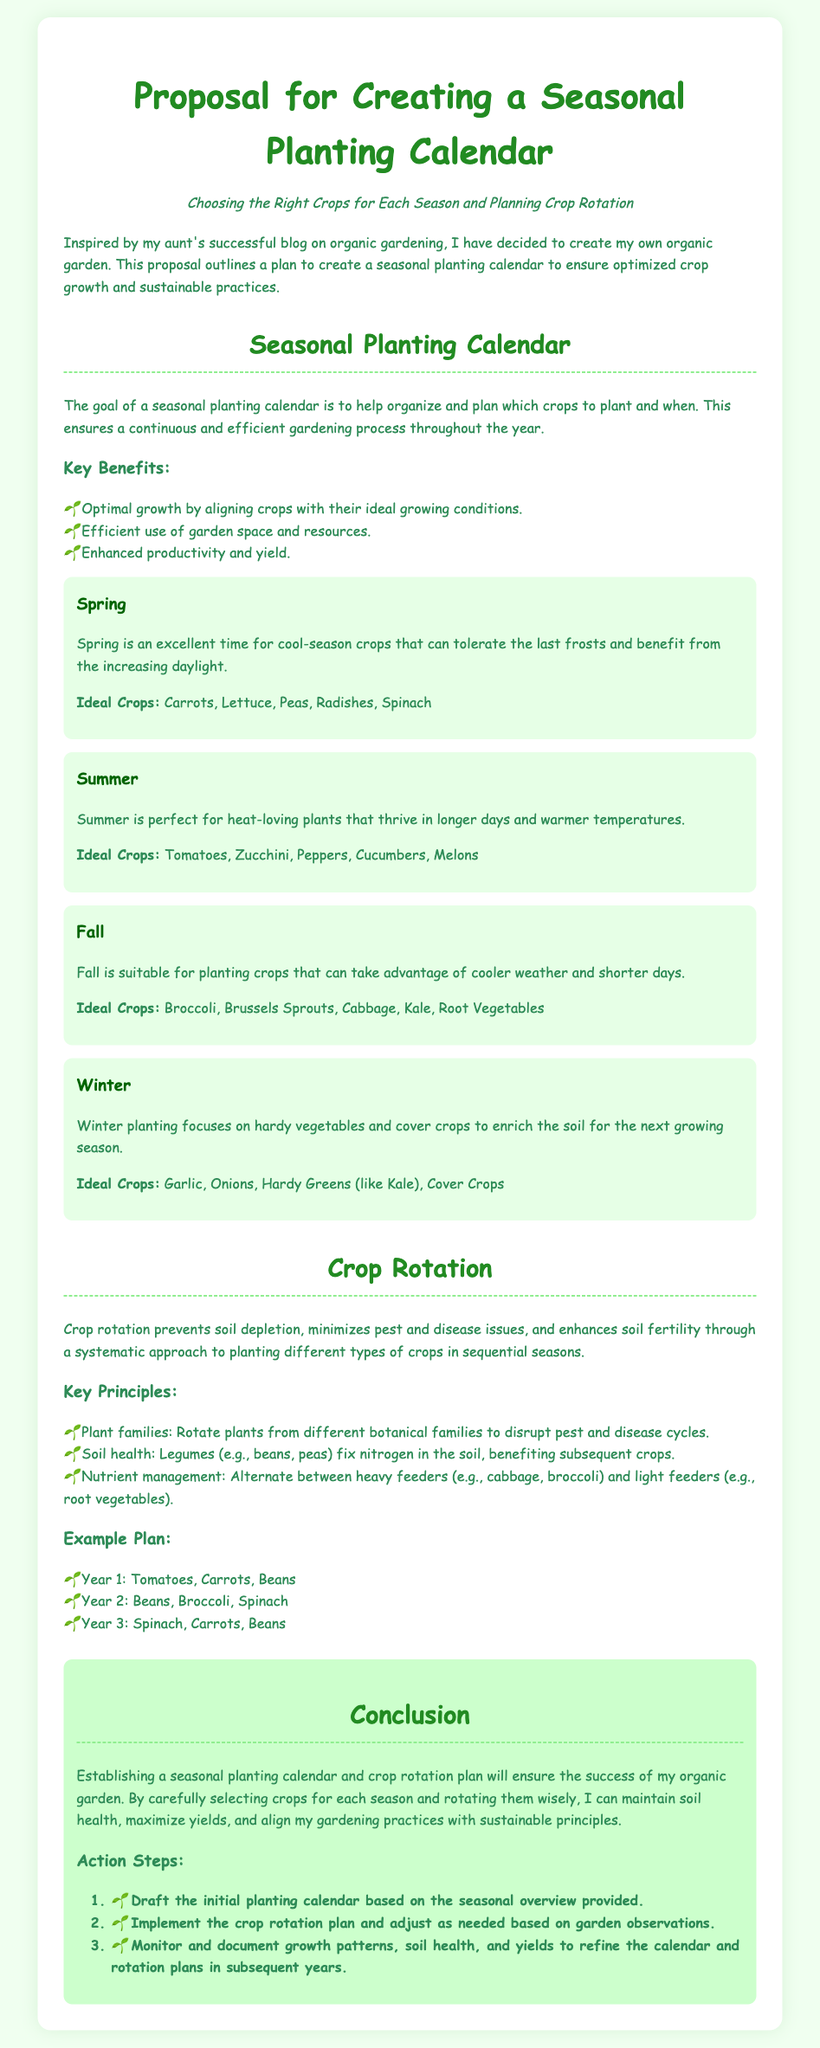What is the purpose of the seasonal planting calendar? The purpose is to help organize and plan which crops to plant and when, ensuring a continuous and efficient gardening process throughout the year.
Answer: Organize and plan crop planting What crops are ideal for summer planting? The document lists the ideal crops for summer planting, focusing on those that thrive in warmer temperatures.
Answer: Tomatoes, Zucchini, Peppers, Cucumbers, Melons What key principle of crop rotation involves alternating heavy and light feeders? This principle aims to manage the nutrients in the soil by rotating crops based on their nutrient needs.
Answer: Nutrient management How many action steps are outlined in the conclusion? The document specifies the number of action steps to take as part of the proposal.
Answer: Three What is a cool-season crop mentioned for spring planting? The document provides a specific example of a crop that is well-suited for spring conditions.
Answer: Spinach Which season focuses on planting hardy vegetables and cover crops? The document categorizes the types of crops planted during a particular season and their growth characteristics.
Answer: Winter What is one benefit of creating a seasonal planting calendar? The document outlines several benefits related to gardening efficiency and productivity.
Answer: Optimal growth What will I monitor and document for refining my planting strategies? The proposal emphasizes the importance of observation in guiding gardening practices for improvement.
Answer: Growth patterns, soil health, yields 